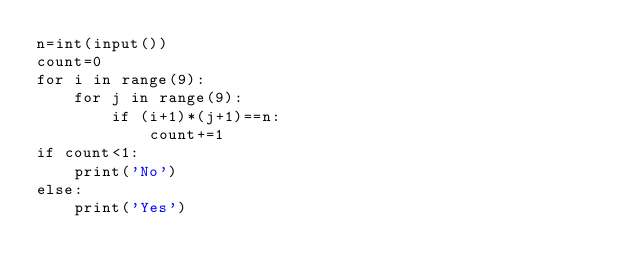Convert code to text. <code><loc_0><loc_0><loc_500><loc_500><_Python_>n=int(input())
count=0
for i in range(9):
    for j in range(9):
        if (i+1)*(j+1)==n:
            count+=1
if count<1:
    print('No')
else:
    print('Yes')</code> 